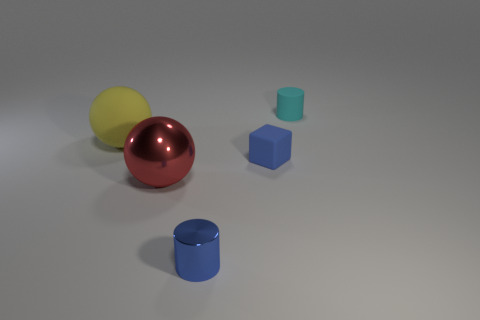How many rubber balls have the same size as the red shiny sphere?
Your response must be concise. 1. How many other objects are there of the same color as the small cube?
Make the answer very short. 1. There is a tiny rubber thing on the left side of the small cyan matte thing; is its shape the same as the tiny thing that is in front of the red metal object?
Offer a very short reply. No. What shape is the yellow matte thing that is the same size as the red shiny object?
Keep it short and to the point. Sphere. Are there the same number of tiny blue blocks on the left side of the rubber sphere and small blue things that are to the left of the blue cube?
Offer a terse response. No. Is there anything else that is the same shape as the blue rubber object?
Give a very brief answer. No. Is the material of the tiny cylinder that is behind the tiny blue cylinder the same as the tiny blue cylinder?
Make the answer very short. No. There is another ball that is the same size as the red sphere; what is it made of?
Provide a short and direct response. Rubber. What number of other things are there of the same material as the large red sphere
Ensure brevity in your answer.  1. Do the yellow matte ball and the cylinder in front of the small matte cylinder have the same size?
Give a very brief answer. No. 